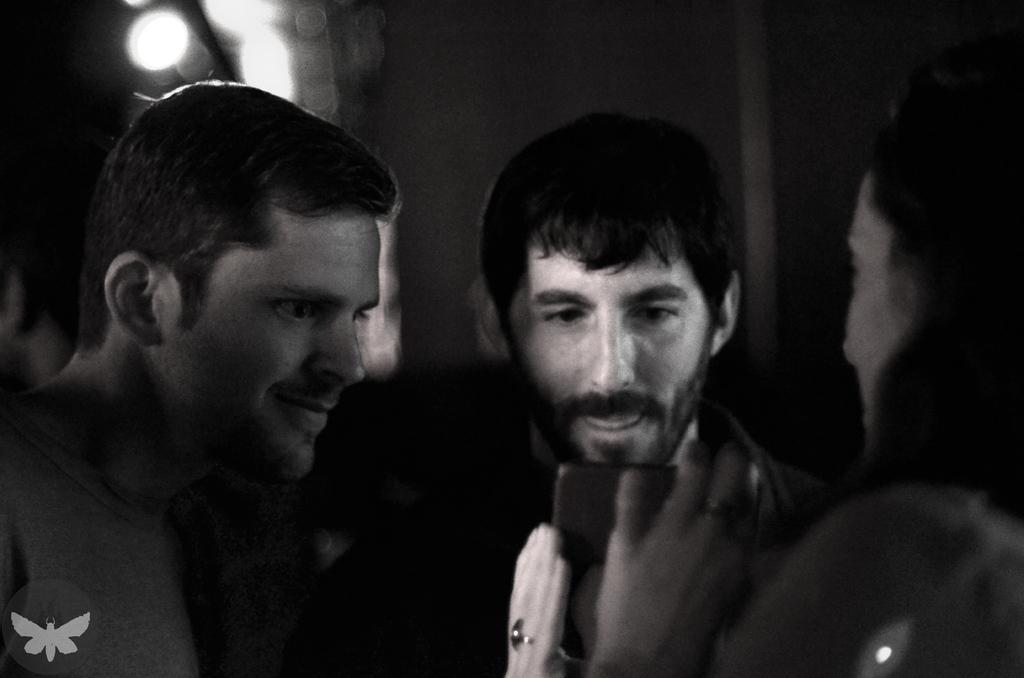How would you summarize this image in a sentence or two? This is a black and white picture. Background portion of the picture is blurred. In this picture we can see people. We can see a person holding an object and it looks like a mobile. We can see men are staring at a mobile. In the bottom left corner of the picture we can see watermark. 